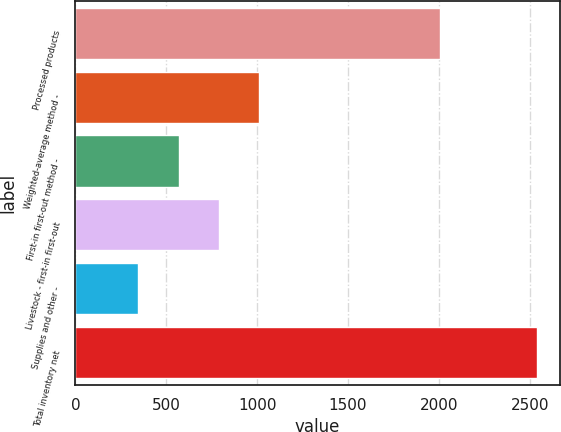Convert chart. <chart><loc_0><loc_0><loc_500><loc_500><bar_chart><fcel>Processed products<fcel>Weighted-average method -<fcel>First-in first-out method -<fcel>Livestock - first-in first-out<fcel>Supplies and other -<fcel>Total inventory net<nl><fcel>2008<fcel>1009.4<fcel>571<fcel>790.2<fcel>346<fcel>2538<nl></chart> 